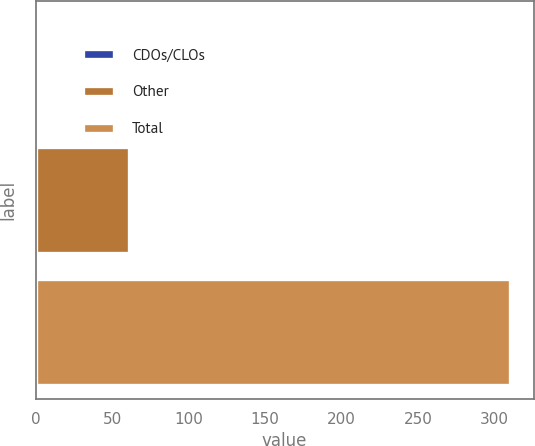Convert chart. <chart><loc_0><loc_0><loc_500><loc_500><bar_chart><fcel>CDOs/CLOs<fcel>Other<fcel>Total<nl><fcel>1<fcel>61<fcel>310<nl></chart> 